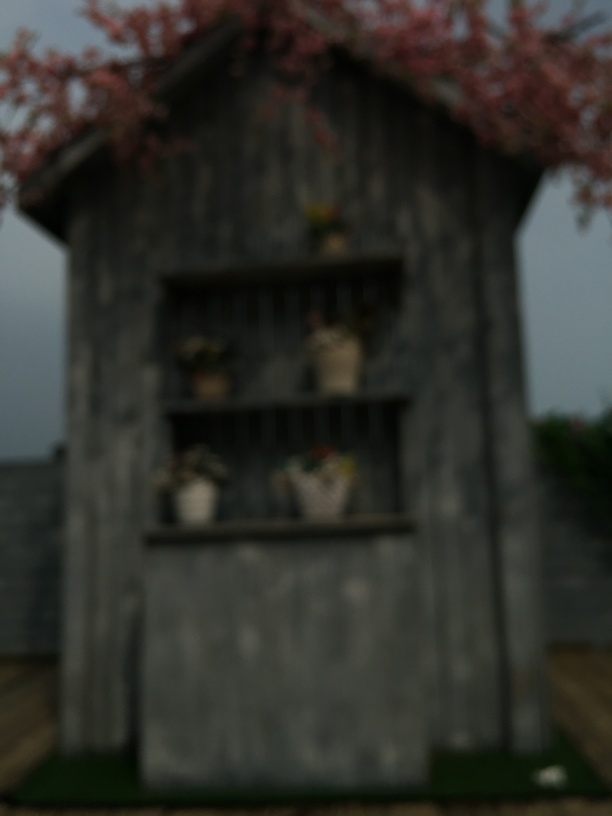Are there any quality issues with this image? Yes, the image is blurry which obscures the details and makes it difficult to clearly discern the subjects in the photo, such as the structure of the building and the objects or possible decorations displayed. 